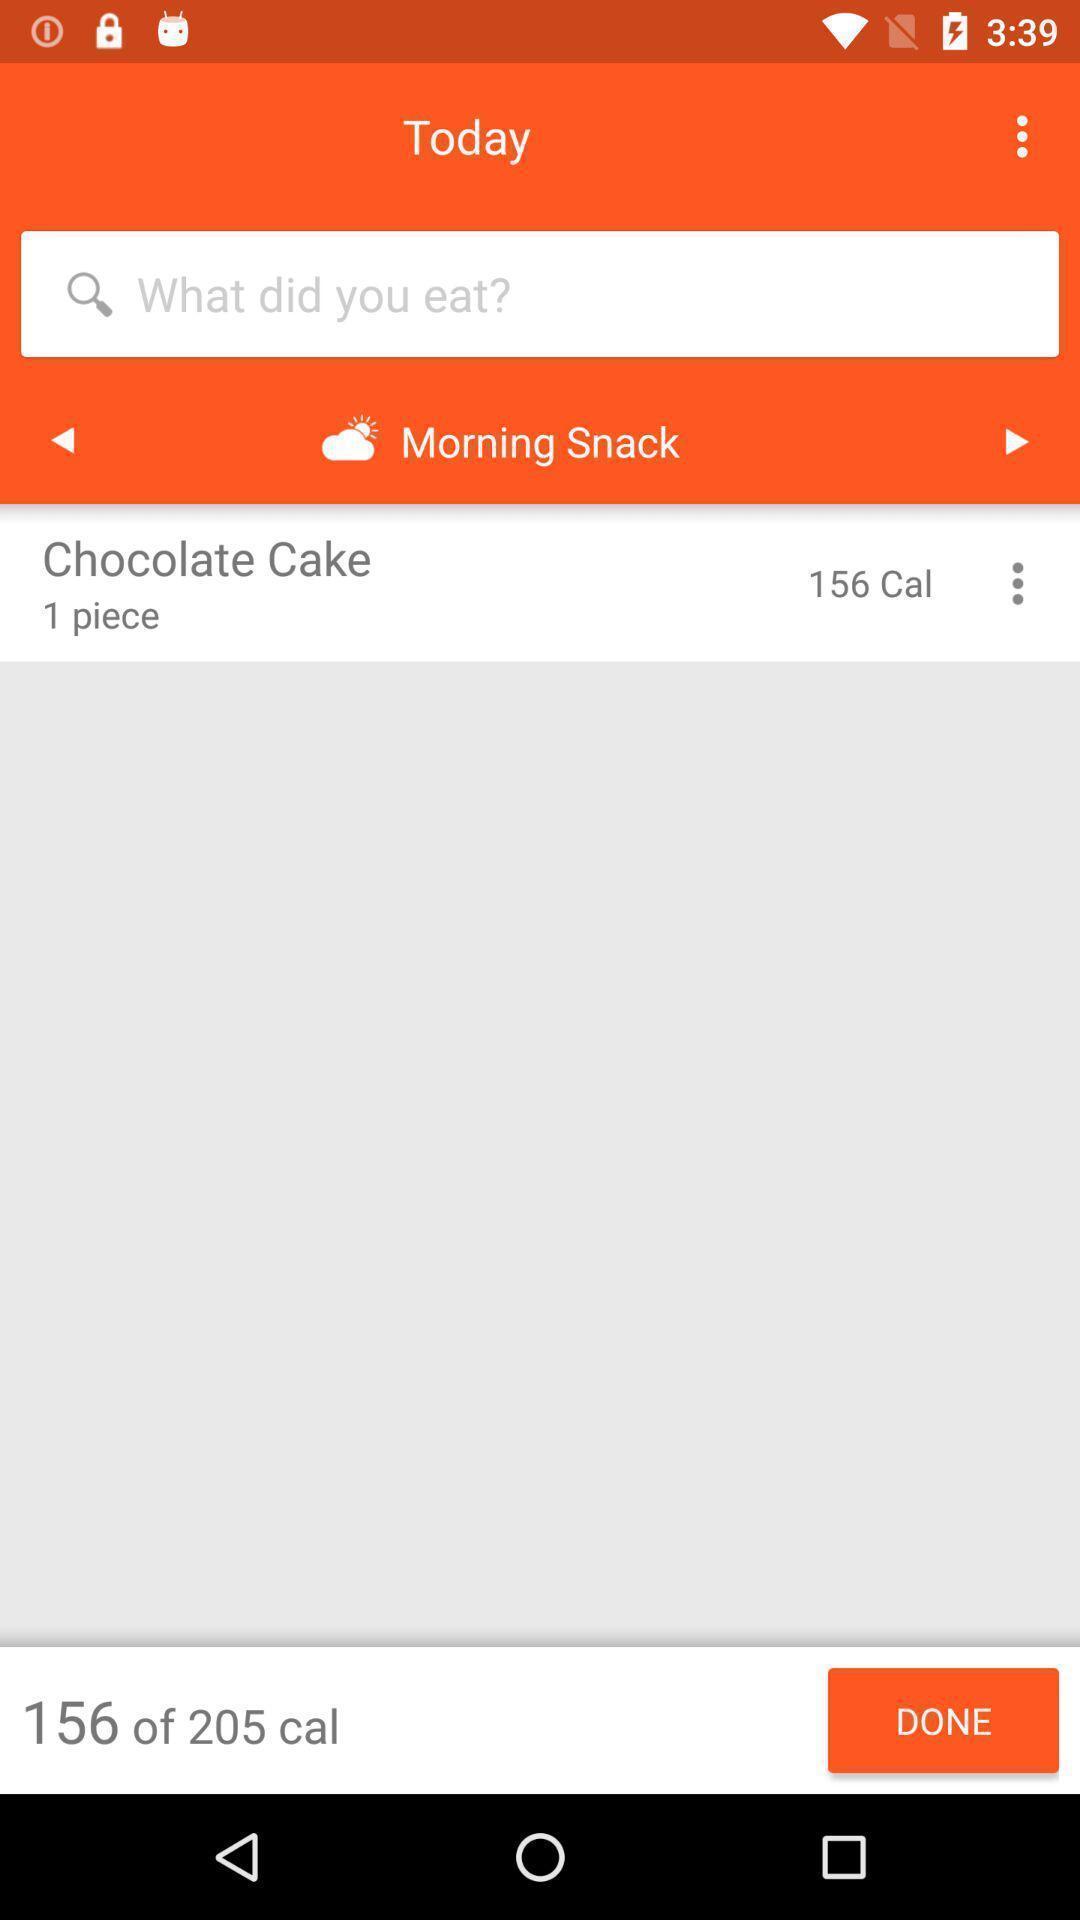What details can you identify in this image? Weight and health diet chat app. 